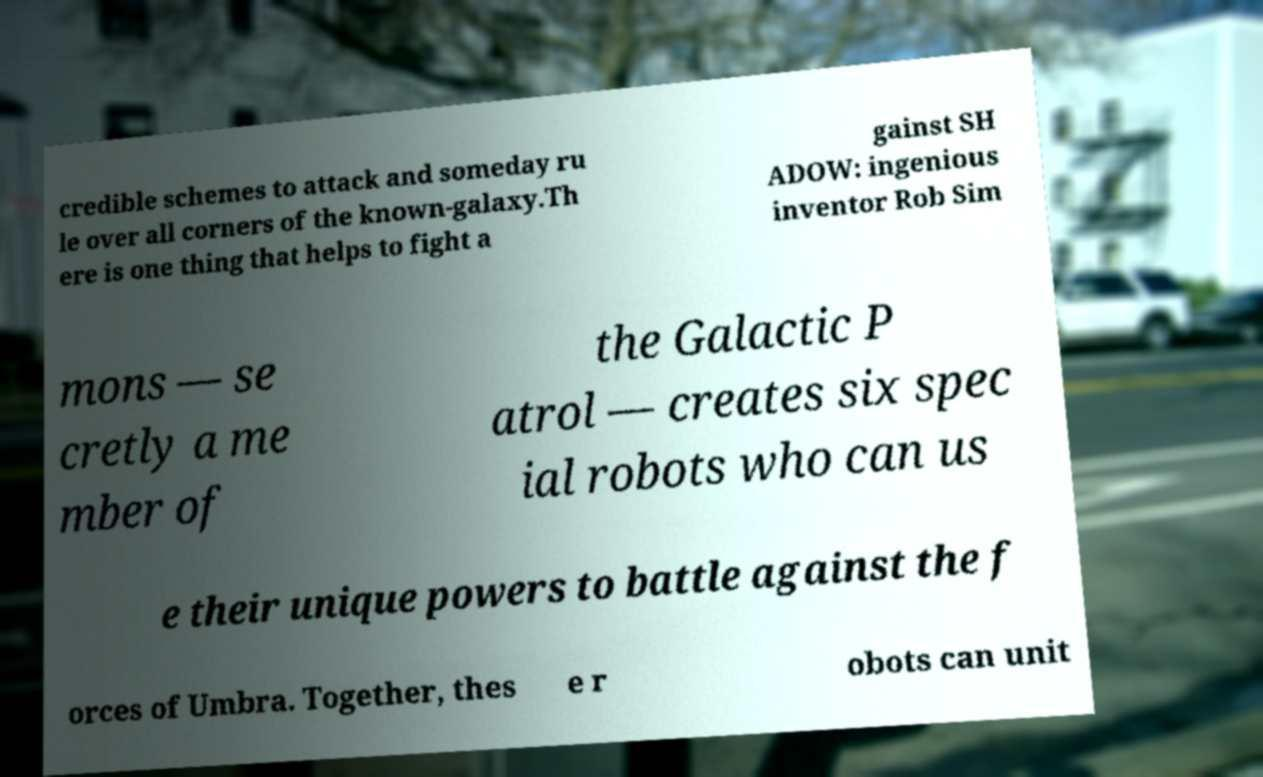Please identify and transcribe the text found in this image. credible schemes to attack and someday ru le over all corners of the known-galaxy.Th ere is one thing that helps to fight a gainst SH ADOW: ingenious inventor Rob Sim mons — se cretly a me mber of the Galactic P atrol — creates six spec ial robots who can us e their unique powers to battle against the f orces of Umbra. Together, thes e r obots can unit 